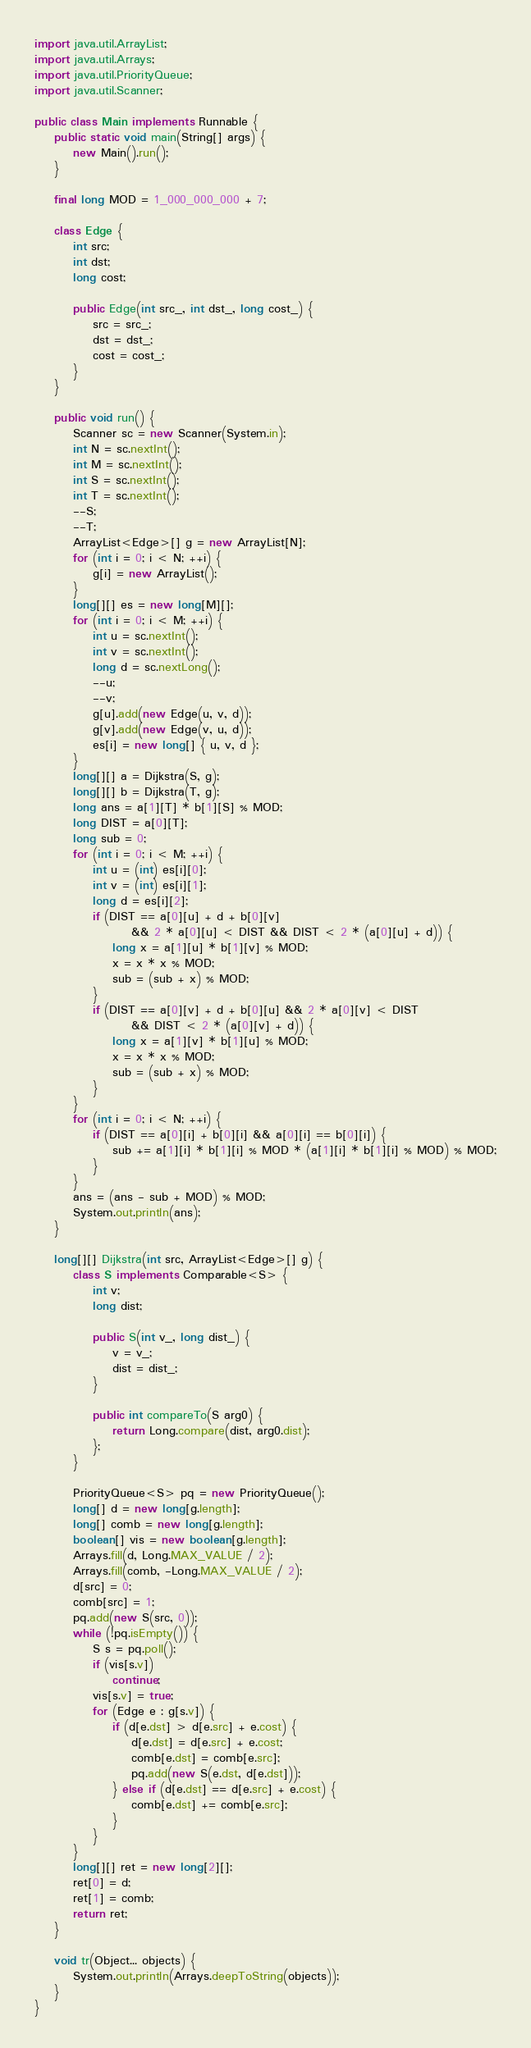Convert code to text. <code><loc_0><loc_0><loc_500><loc_500><_Java_>import java.util.ArrayList;
import java.util.Arrays;
import java.util.PriorityQueue;
import java.util.Scanner;

public class Main implements Runnable {
	public static void main(String[] args) {
		new Main().run();
	}

	final long MOD = 1_000_000_000 + 7;

	class Edge {
		int src;
		int dst;
		long cost;

		public Edge(int src_, int dst_, long cost_) {
			src = src_;
			dst = dst_;
			cost = cost_;
		}
	}

	public void run() {
		Scanner sc = new Scanner(System.in);
		int N = sc.nextInt();
		int M = sc.nextInt();
		int S = sc.nextInt();
		int T = sc.nextInt();
		--S;
		--T;
		ArrayList<Edge>[] g = new ArrayList[N];
		for (int i = 0; i < N; ++i) {
			g[i] = new ArrayList();
		}
		long[][] es = new long[M][];
		for (int i = 0; i < M; ++i) {
			int u = sc.nextInt();
			int v = sc.nextInt();
			long d = sc.nextLong();
			--u;
			--v;
			g[u].add(new Edge(u, v, d));
			g[v].add(new Edge(v, u, d));
			es[i] = new long[] { u, v, d };
		}
		long[][] a = Dijkstra(S, g);
		long[][] b = Dijkstra(T, g);
		long ans = a[1][T] * b[1][S] % MOD;
		long DIST = a[0][T];
		long sub = 0;
		for (int i = 0; i < M; ++i) {
			int u = (int) es[i][0];
			int v = (int) es[i][1];
			long d = es[i][2];
			if (DIST == a[0][u] + d + b[0][v]
					&& 2 * a[0][u] < DIST && DIST < 2 * (a[0][u] + d)) {
				long x = a[1][u] * b[1][v] % MOD;
				x = x * x % MOD;
				sub = (sub + x) % MOD;
			}
			if (DIST == a[0][v] + d + b[0][u] && 2 * a[0][v] < DIST
					&& DIST < 2 * (a[0][v] + d)) {
				long x = a[1][v] * b[1][u] % MOD;
				x = x * x % MOD;
				sub = (sub + x) % MOD;
			}
		}
		for (int i = 0; i < N; ++i) {
			if (DIST == a[0][i] + b[0][i] && a[0][i] == b[0][i]) {
				sub += a[1][i] * b[1][i] % MOD * (a[1][i] * b[1][i] % MOD) % MOD;
			}
		}
		ans = (ans - sub + MOD) % MOD;
		System.out.println(ans);
	}

	long[][] Dijkstra(int src, ArrayList<Edge>[] g) {
		class S implements Comparable<S> {
			int v;
			long dist;

			public S(int v_, long dist_) {
				v = v_;
				dist = dist_;
			}

			public int compareTo(S arg0) {
				return Long.compare(dist, arg0.dist);
			};
		}

		PriorityQueue<S> pq = new PriorityQueue();
		long[] d = new long[g.length];
		long[] comb = new long[g.length];
		boolean[] vis = new boolean[g.length];
		Arrays.fill(d, Long.MAX_VALUE / 2);
		Arrays.fill(comb, -Long.MAX_VALUE / 2);
		d[src] = 0;
		comb[src] = 1;
		pq.add(new S(src, 0));
		while (!pq.isEmpty()) {
			S s = pq.poll();
			if (vis[s.v])
				continue;
			vis[s.v] = true;
			for (Edge e : g[s.v]) {
				if (d[e.dst] > d[e.src] + e.cost) {
					d[e.dst] = d[e.src] + e.cost;
					comb[e.dst] = comb[e.src];
					pq.add(new S(e.dst, d[e.dst]));
				} else if (d[e.dst] == d[e.src] + e.cost) {
					comb[e.dst] += comb[e.src];
				}
			}
		}
		long[][] ret = new long[2][];
		ret[0] = d;
		ret[1] = comb;
		return ret;
	}

	void tr(Object... objects) {
		System.out.println(Arrays.deepToString(objects));
	}
}
</code> 